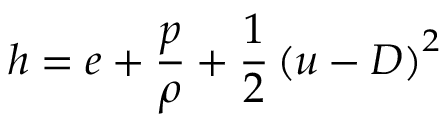<formula> <loc_0><loc_0><loc_500><loc_500>h = e + \frac { p } { \rho } + \frac { 1 } { 2 } \left ( u - D \right ) ^ { 2 }</formula> 